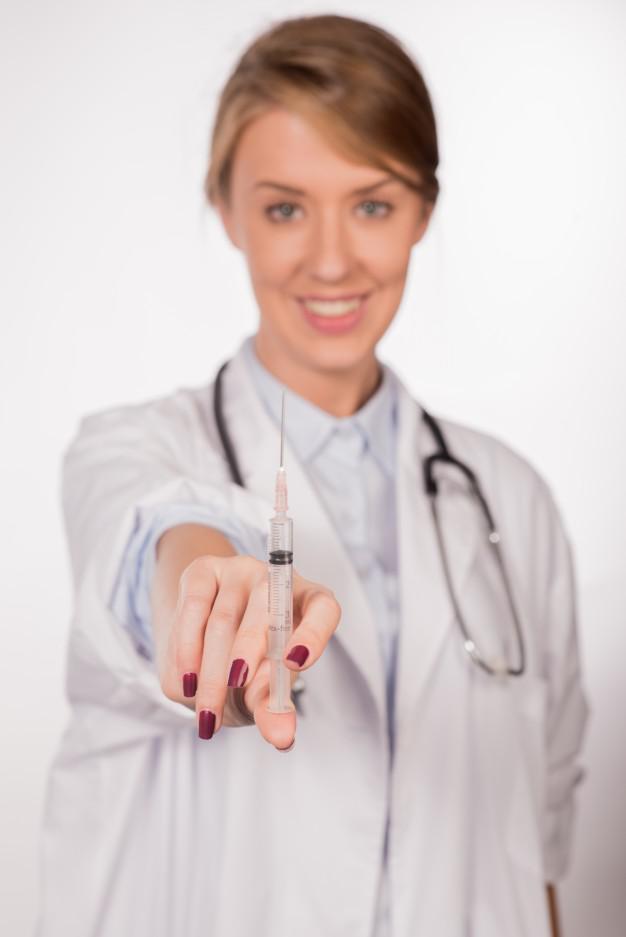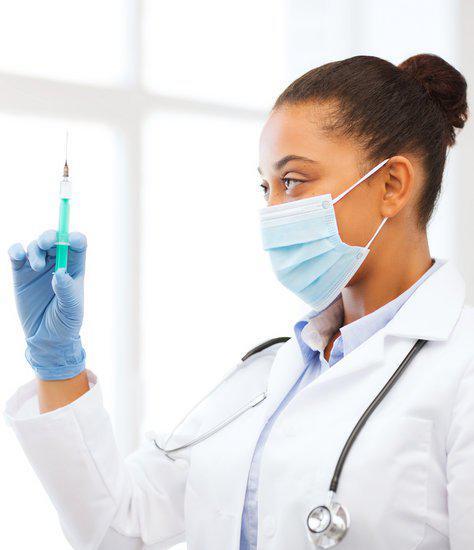The first image is the image on the left, the second image is the image on the right. Analyze the images presented: Is the assertion "The left image shows a man holding up an aqua-colored syringe with one bare hand." valid? Answer yes or no. No. The first image is the image on the left, the second image is the image on the right. For the images displayed, is the sentence "In at least one of the images, a medical professional is looking directly at a syringe full of blue liquid." factually correct? Answer yes or no. Yes. 